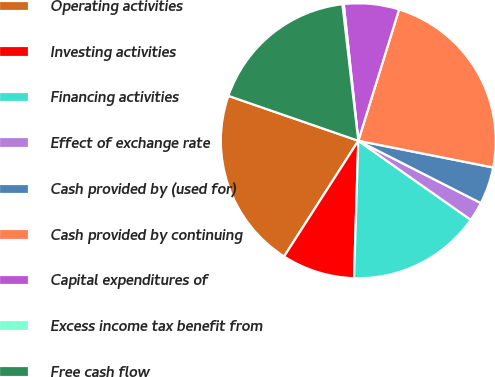Convert chart to OTSL. <chart><loc_0><loc_0><loc_500><loc_500><pie_chart><fcel>Operating activities<fcel>Investing activities<fcel>Financing activities<fcel>Effect of exchange rate<fcel>Cash provided by (used for)<fcel>Cash provided by continuing<fcel>Capital expenditures of<fcel>Excess income tax benefit from<fcel>Free cash flow<nl><fcel>21.22%<fcel>8.58%<fcel>15.74%<fcel>2.27%<fcel>4.37%<fcel>23.32%<fcel>6.48%<fcel>0.16%<fcel>17.85%<nl></chart> 